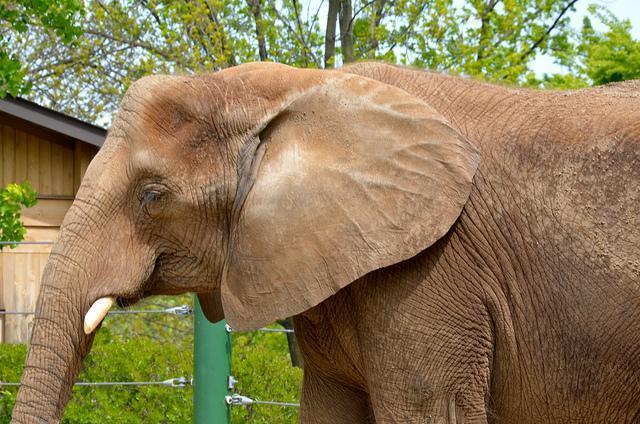How many red suitcases are there in the image?
Give a very brief answer. 0. 